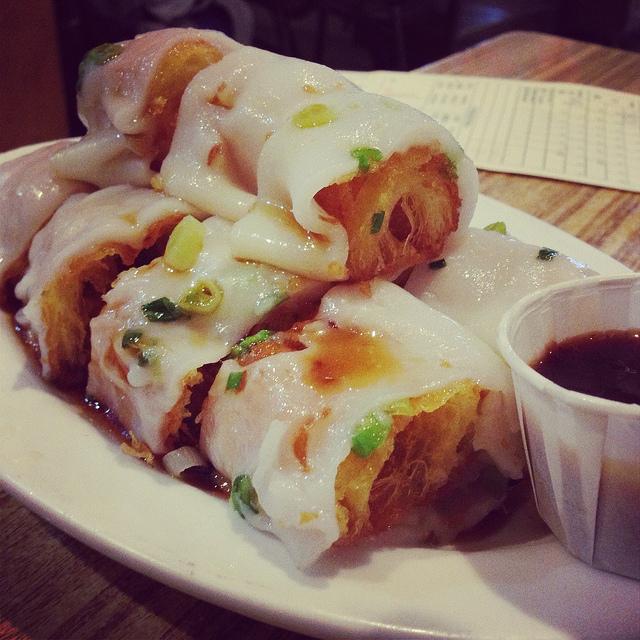What is the surface of the table?
Quick response, please. Wood. What kind of food is this?
Be succinct. Egg roll. What is on this plate?
Give a very brief answer. Food. Is there sauce served with this food?
Keep it brief. Yes. What type of condiment is in the cup?
Concise answer only. Soy sauce. 